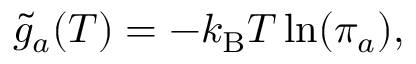<formula> <loc_0><loc_0><loc_500><loc_500>\tilde { g } _ { a } ( T ) = - k _ { B } T \ln ( \pi _ { a } ) ,</formula> 